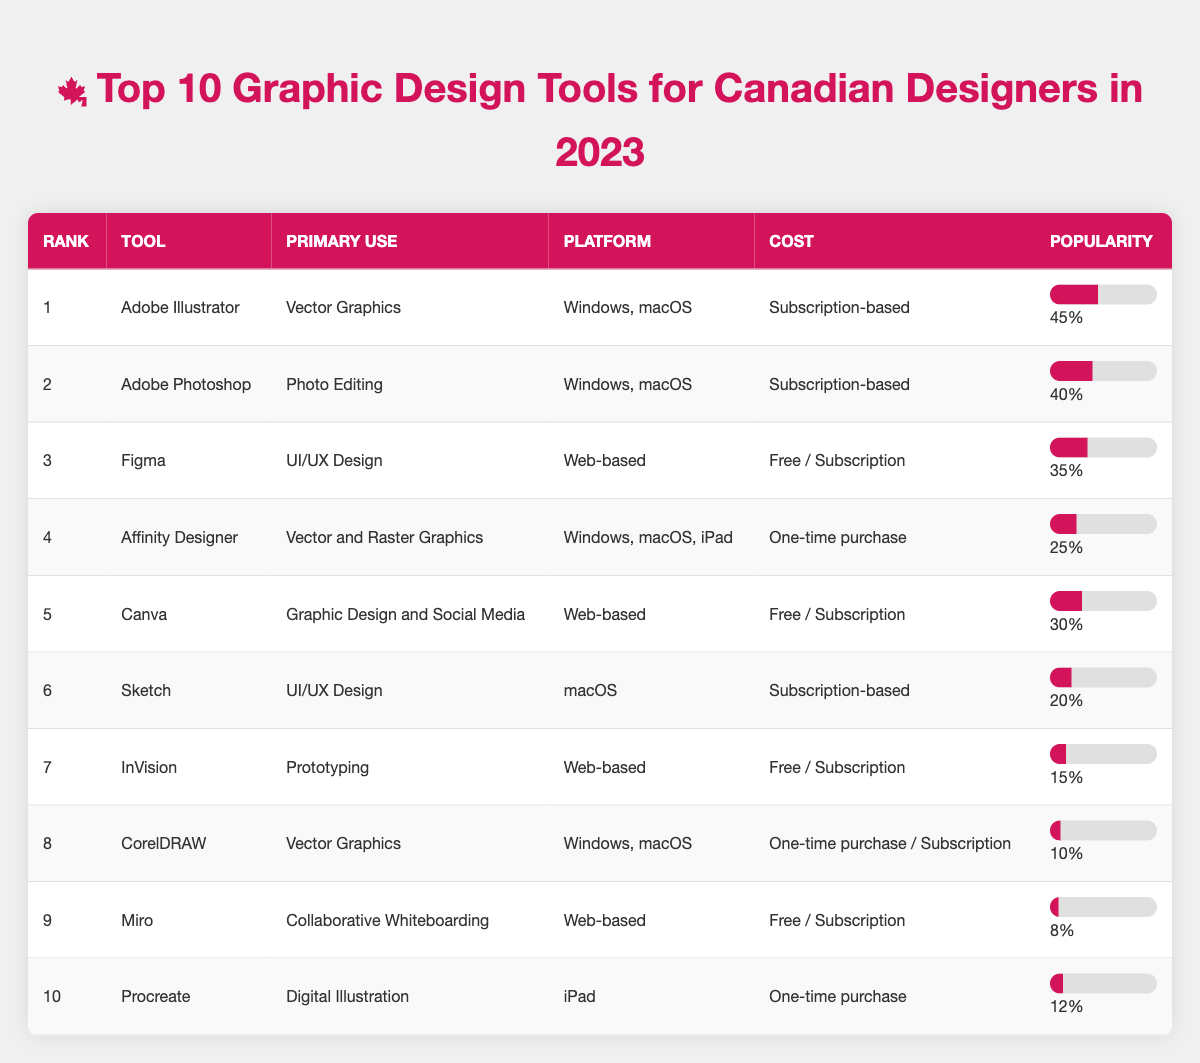What is the primary use of Adobe Illustrator? Adobe Illustrator is listed in the table, and its primary use is mentioned directly in the corresponding row under "Primary Use." It states "Vector Graphics."
Answer: Vector Graphics Which tool is used for Digital Illustration? In the table, the tool listed for Digital Illustration in the "Primary Use" column corresponds to Procreate in the "Tool" column.
Answer: Procreate What is the popularity percentage of Canva? The table shows Canva listed with a popularity percentage in the "Popularity" column. The value is 30%.
Answer: 30% Which tool has the lowest popularity percentage? We check the last row of the table, which indicates Miro has a popularity percentage of 8%, lower than all other tools listed.
Answer: Miro How much more popular is Adobe Illustrator compared to CorelDRAW? We find the popularity percentages of both tools from the table: Adobe Illustrator is 45% and CorelDRAW is 10%. The difference is calculated as 45% - 10% = 35%.
Answer: 35% What is the average popularity percentage of the top three tools? We sum the popularity percentages of the top three tools: 45% (Adobe Illustrator) + 40% (Adobe Photoshop) + 35% (Figma) = 120%. We divide by 3 to get the average: 120% / 3 = 40%.
Answer: 40% Is Figma more popular than Affinity Designer? We compare the popularity percentages in the table: Figma has 35% while Affinity Designer has 25%. Since 35% is greater than 25%, Figma is indeed more popular.
Answer: Yes Which tool has a one-time purchase cost? We look for tools in the table that mention "One-time purchase" under the "Cost" column. Affinity Designer and Procreate both fit this description.
Answer: Affinity Designer and Procreate What percentage of tools use a subscription-based model? We count the number of tools categorized under "Subscription-based" and summarize their popularity percentages: Adobe Illustrator (45%), Adobe Photoshop (40%), Sketch (20%). The total percentage is 45% + 40% + 20% = 105%. There are 3 subscription-based tools out of 10, which gives us 30%.
Answer: 30% If a designer prefers free tools, which ones can they use? We look for tools listed as "Free" in the cost column. Based on the table, Figma, Canva, InVision, and Miro have free or subscription-based options. So, they can choose any of these four tools.
Answer: Figma, Canva, InVision, Miro 